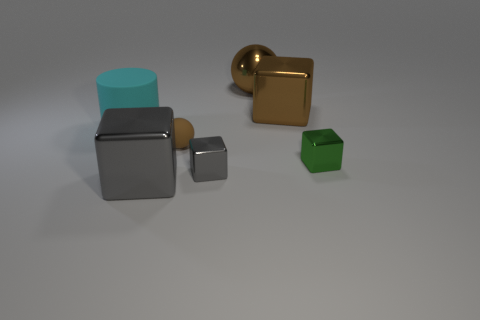What number of matte objects are either tiny gray objects or cyan cubes?
Make the answer very short. 0. The other small object that is the same shape as the small gray object is what color?
Offer a very short reply. Green. Is there a green shiny object?
Your answer should be compact. Yes. Do the ball behind the large matte object and the cube behind the tiny green metal cube have the same material?
Your response must be concise. Yes. There is a shiny thing that is the same color as the large sphere; what is its shape?
Keep it short and to the point. Cube. How many things are metal blocks that are behind the big gray metal block or gray objects left of the small brown sphere?
Give a very brief answer. 4. There is a tiny block that is left of the metallic ball; is it the same color as the thing that is on the left side of the large gray shiny cube?
Offer a very short reply. No. What is the shape of the big thing that is behind the large cyan rubber cylinder and left of the brown metallic cube?
Provide a short and direct response. Sphere. There is a shiny ball that is the same size as the cyan thing; what color is it?
Provide a succinct answer. Brown. Are there any small matte balls of the same color as the matte cylinder?
Make the answer very short. No. 